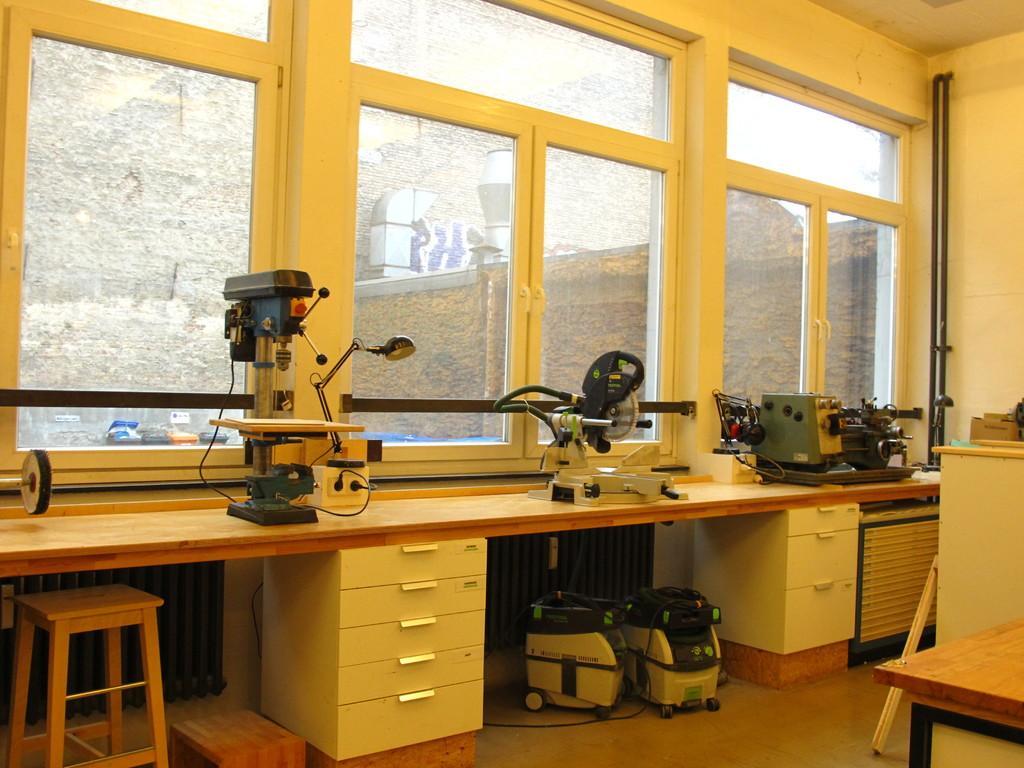Please provide a concise description of this image. This picture is of inside the room. In the center there is a table on the top of which some machines are placed and there are two machines and a stool placed under the table. On the right we can see another table. In the background there is a wall, metal rods, windows, through the window we can see a stone wall and some items placed on the top of the shelf. 